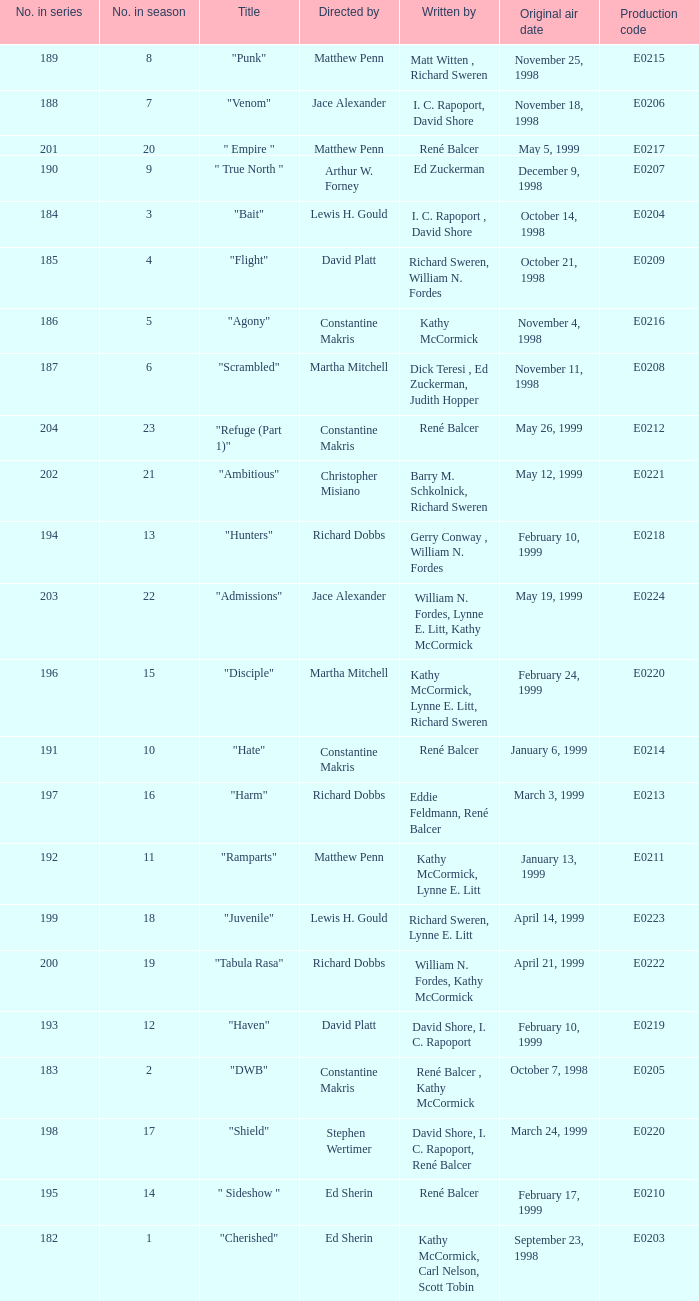The episode with original air date January 13, 1999 is written by who? Kathy McCormick, Lynne E. Litt. 